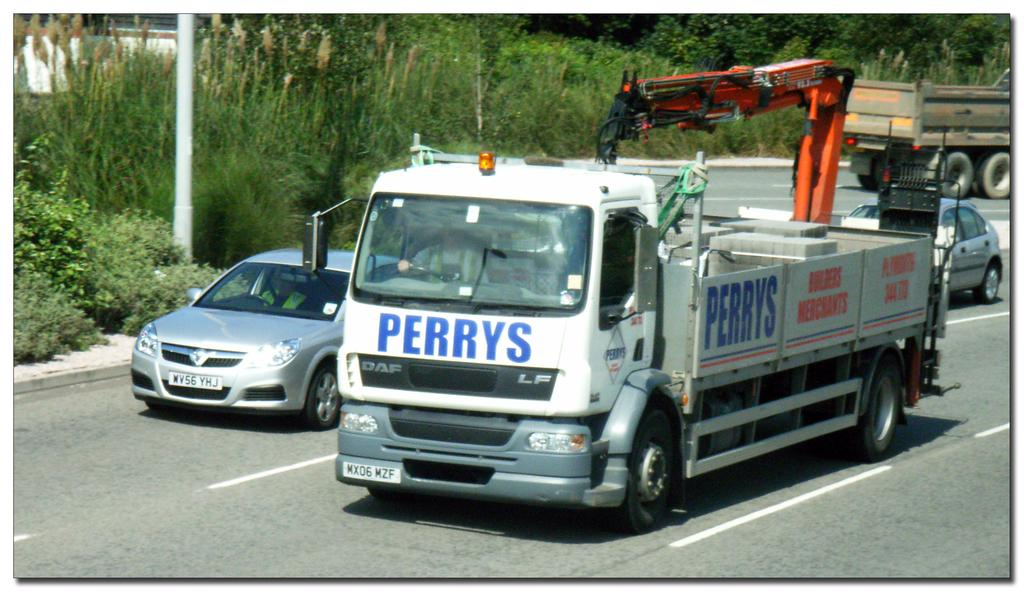What type of vehicles are in the image? There is a car and a truck in the image. What feature does the truck have? The truck has a crane. Where are the car and truck located? They are on a road in the image. What type of vegetation can be seen in the image? There are plants and trees in the image. What type of property is being sold by the car dealer in the image? There is no car dealer or property being sold in the image; it only features a car and a truck with a crane on a road. Can you tell me what is inside the locket that the driver of the truck is wearing in the image? There is no locket or driver visible in the image; it only features a car and a truck with a crane on a road. 